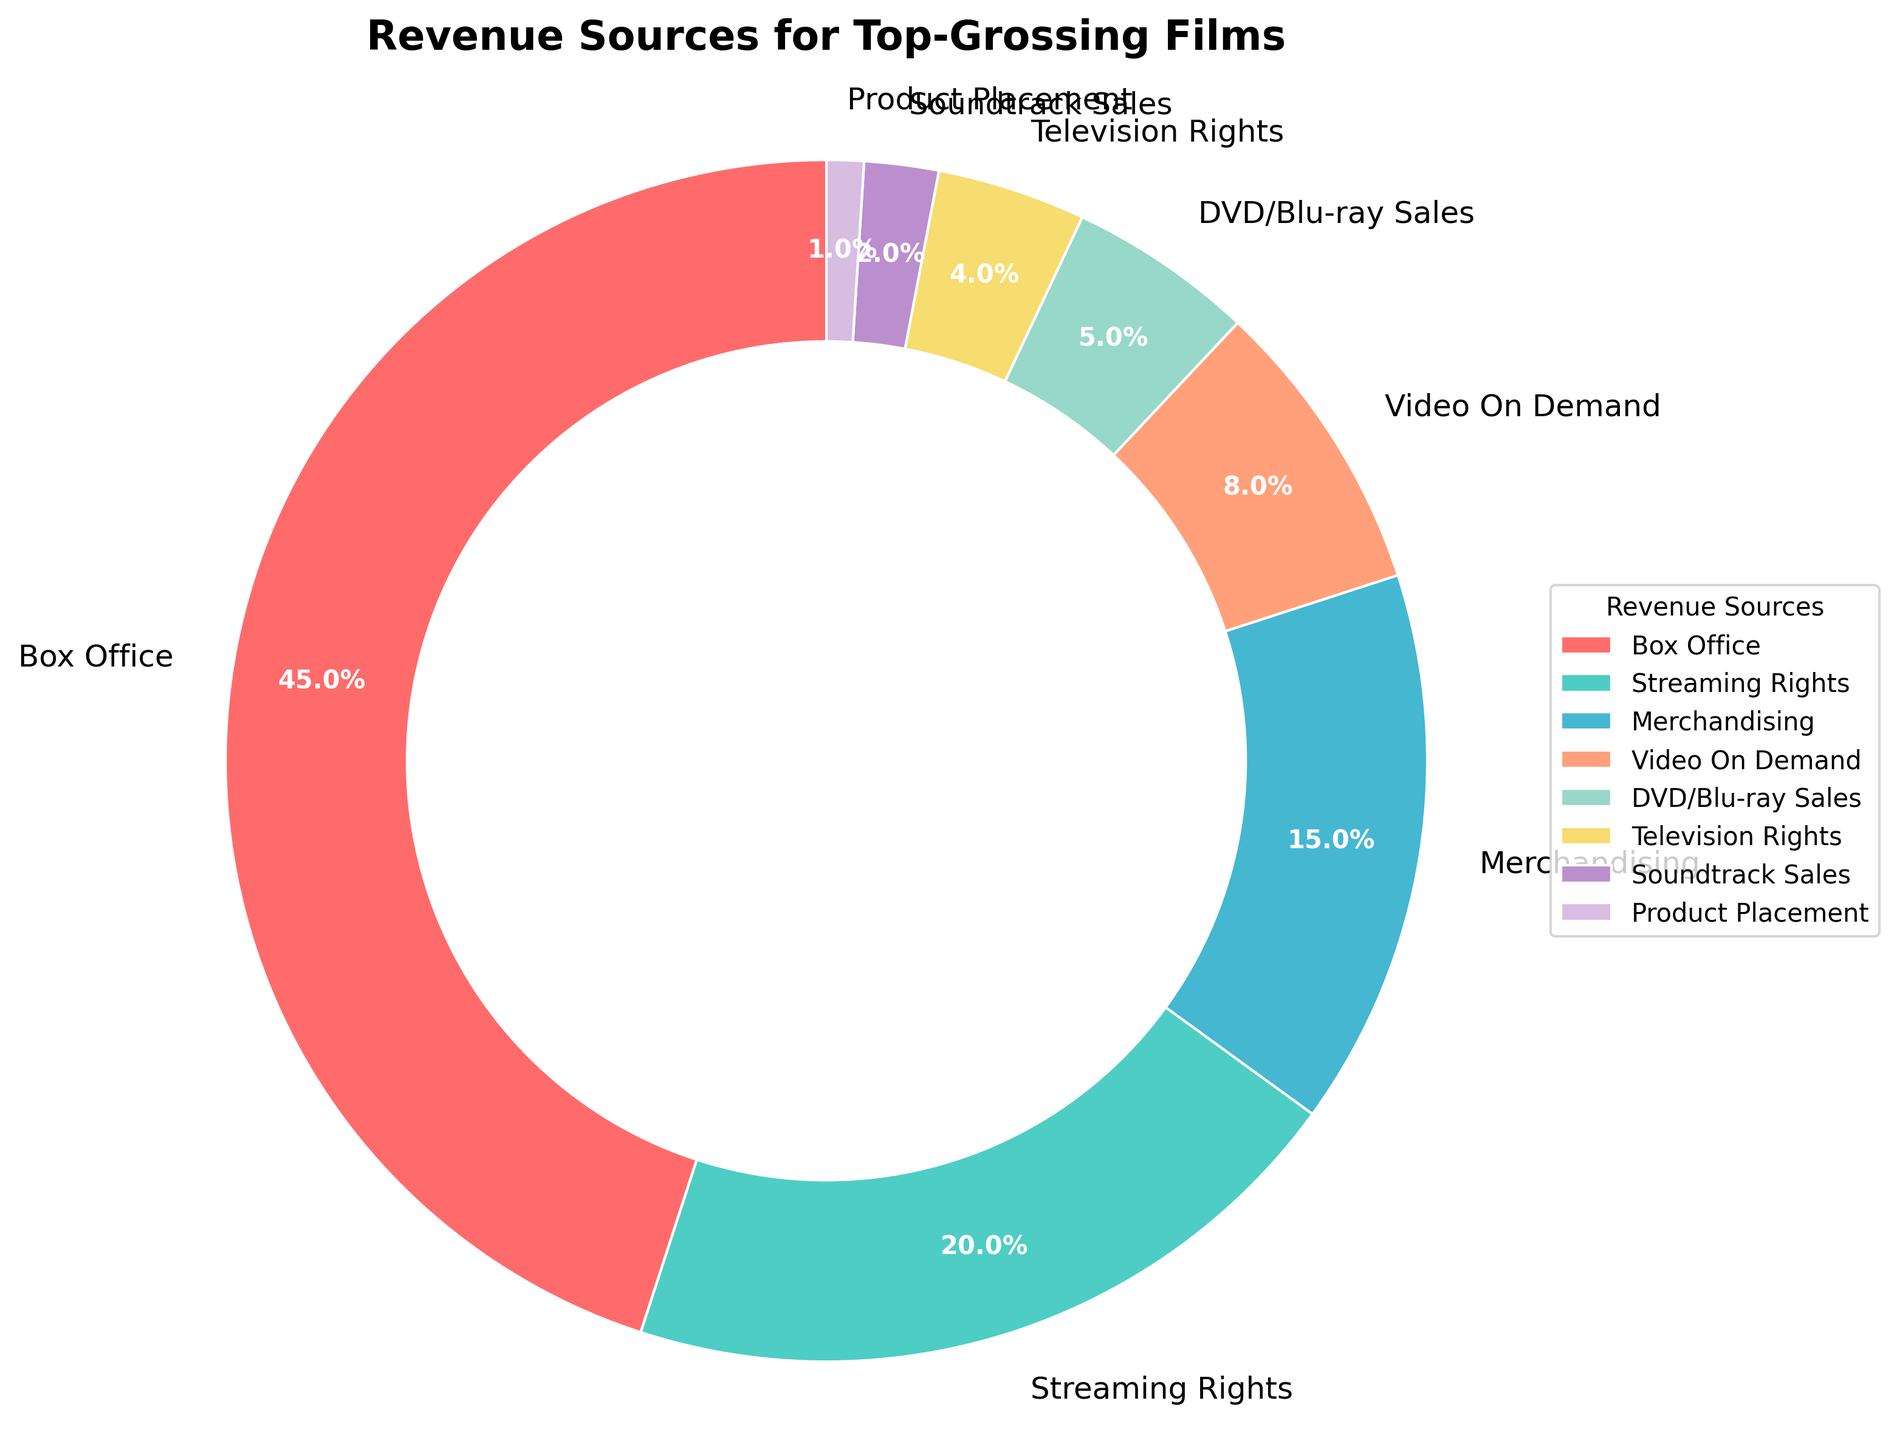What's the largest revenue source for top-grossing films? The pie chart indicates the largest section, labeled "Box Office" with its percentage.
Answer: Box Office What's the total percentage of revenue from Box Office and Streaming Rights combined? Add the percentages for "Box Office" (45) and "Streaming Rights" (20): 45 + 20 = 65.
Answer: 65% Which revenue source brings in more, Merchandising or Video On Demand? Compare the two segments labeled "Merchandising" (15%) and "Video On Demand" (8%).
Answer: Merchandising What is the difference in revenue percentage between DVD/Blu-ray Sales and Television Rights? Subtract Television Rights (4%) from DVD/Blu-ray Sales (5%): 5 - 4 = 1.
Answer: 1% How much more revenue does Streaming Rights generate compared to Soundtrack Sales? Subtract Soundtrack Sales (2%) from Streaming Rights (20%): 20 - 2 = 18.
Answer: 18% Which is the smallest revenue source visually depicted in the chart? The smallest section in the pie chart is labeled "Product Placement" with 1%.
Answer: Product Placement What is the combined revenue percentage for all sources other than Box Office? Sum the percentages for all sources except Box Office: 20 + 15 + 8 + 5 + 4 + 2 + 1 = 55.
Answer: 55% Which revenue sources have percentages greater than 10%? The segments labeled "Box Office" (45%), "Streaming Rights" (20%), and "Merchandising" (15%).
Answer: Box Office, Streaming Rights, Merchandising 